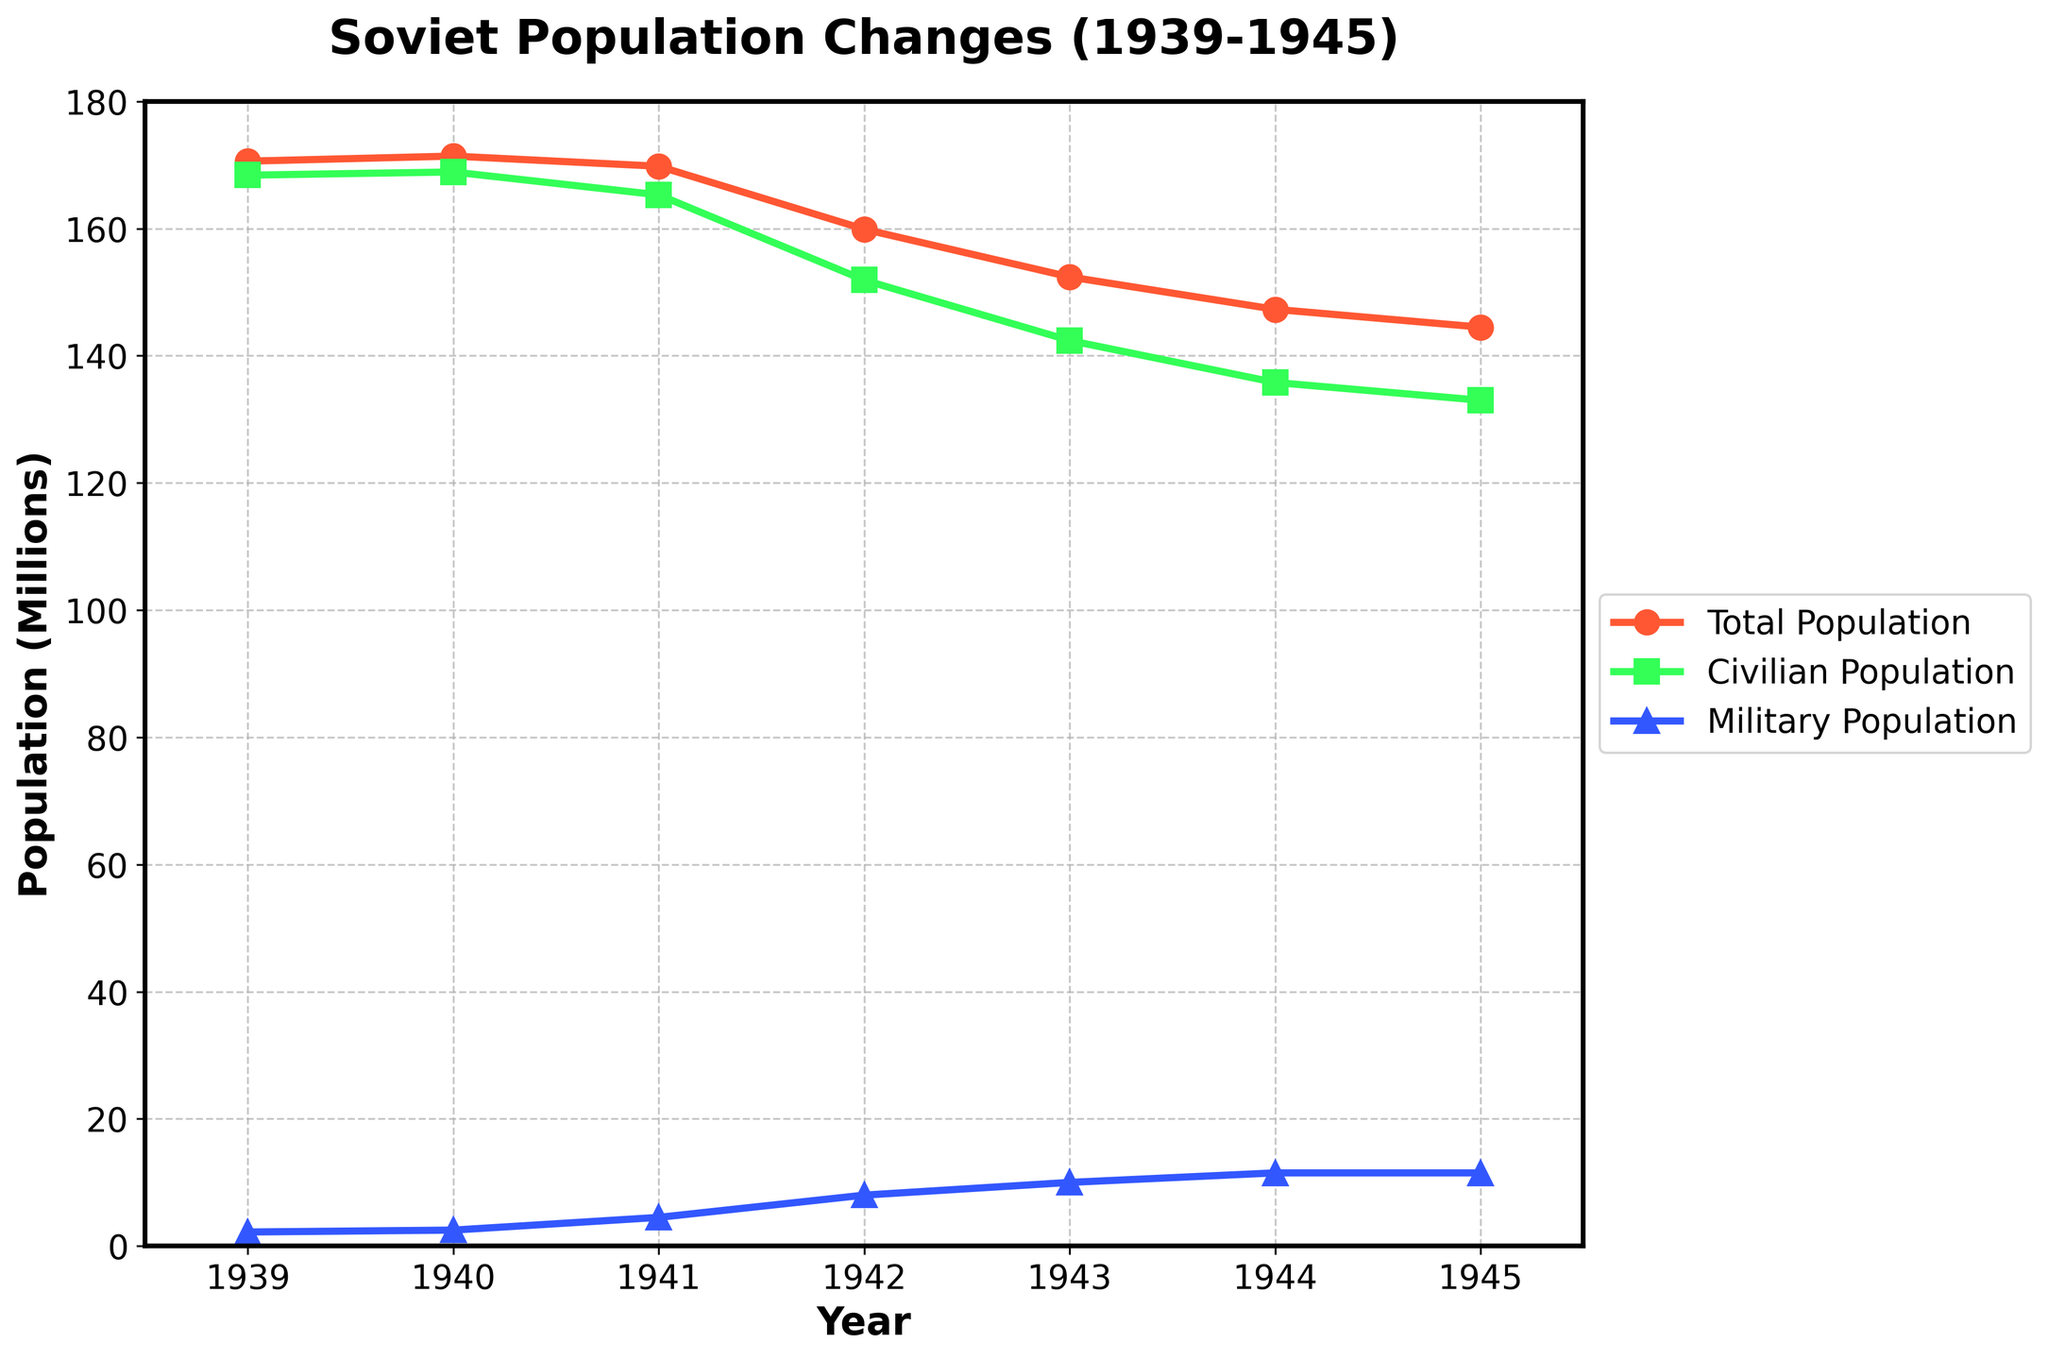What was the total population of the Soviet Union in 1943? The total population data series shows that the value for 1943 is labeled. The chart line for the Total Population in 1943 is at 152.4 million.
Answer: 152.4 million Which year experienced the most significant drop in civilian population? By examining the decline in civilian population line, the largest drop appears between the years 1940 and 1941. Comparing all yearly declines, the civilian population decreased by about 4 million from 1940 to 1941.
Answer: Between 1940 and 1941 How much did the military population increase from 1939 to 1942? First, identify the military population in both years: 2.2 million in 1939 and 8 million in 1942. The increase is 8 million - 2.2 million = 5.8 million.
Answer: 5.8 million Compare the total population in 1941 and 1945. By how much did it decrease? Looking at the total population line for both years, in 1941 it is around 169.8 million, and in 1945 it is approximately 144.5 million. The decrease is 169.8 million - 144.5 million = 25.3 million.
Answer: 25.3 million What was the trend in the military population between 1943 and 1945? The military population line shows it was at 10 million in 1943 and stayed consistent at 11.5 million between 1944 and 1945.
Answer: It increased and then remained stable Which population's visual line appears in green, and how did it change from 1939 to 1945? The green line corresponds to the civilian population. It decreases from around 168.4 million in 1939 to approximately 133 million in 1945.
Answer: Civilian; decreased Was the total population ever higher than 170 million after 1939? Observing the total population line, it crosses the 170 million mark only in 1939 and 1940. Post-1940, it never returns to 170 million.
Answer: No What is the average military population over the seven years (1939-1945)? Sum the military population values: 2.2 + 2.5 + 4.5 + 8 + 10 + 11.5 + 11.5 = 50.2 million. Divide by 7: 50.2 / 7 ≈ 7.17 million.
Answer: Approximately 7.17 million Between which consecutive years did the total and civilian populations both show significant decline? The largest concurrent decline for both total and civilian lines happens between 1940 and 1941. The total drops from 171.4 million to 169.8 million and the civilian from 168.9 million to 165.3 million.
Answer: Between 1940 and 1941 